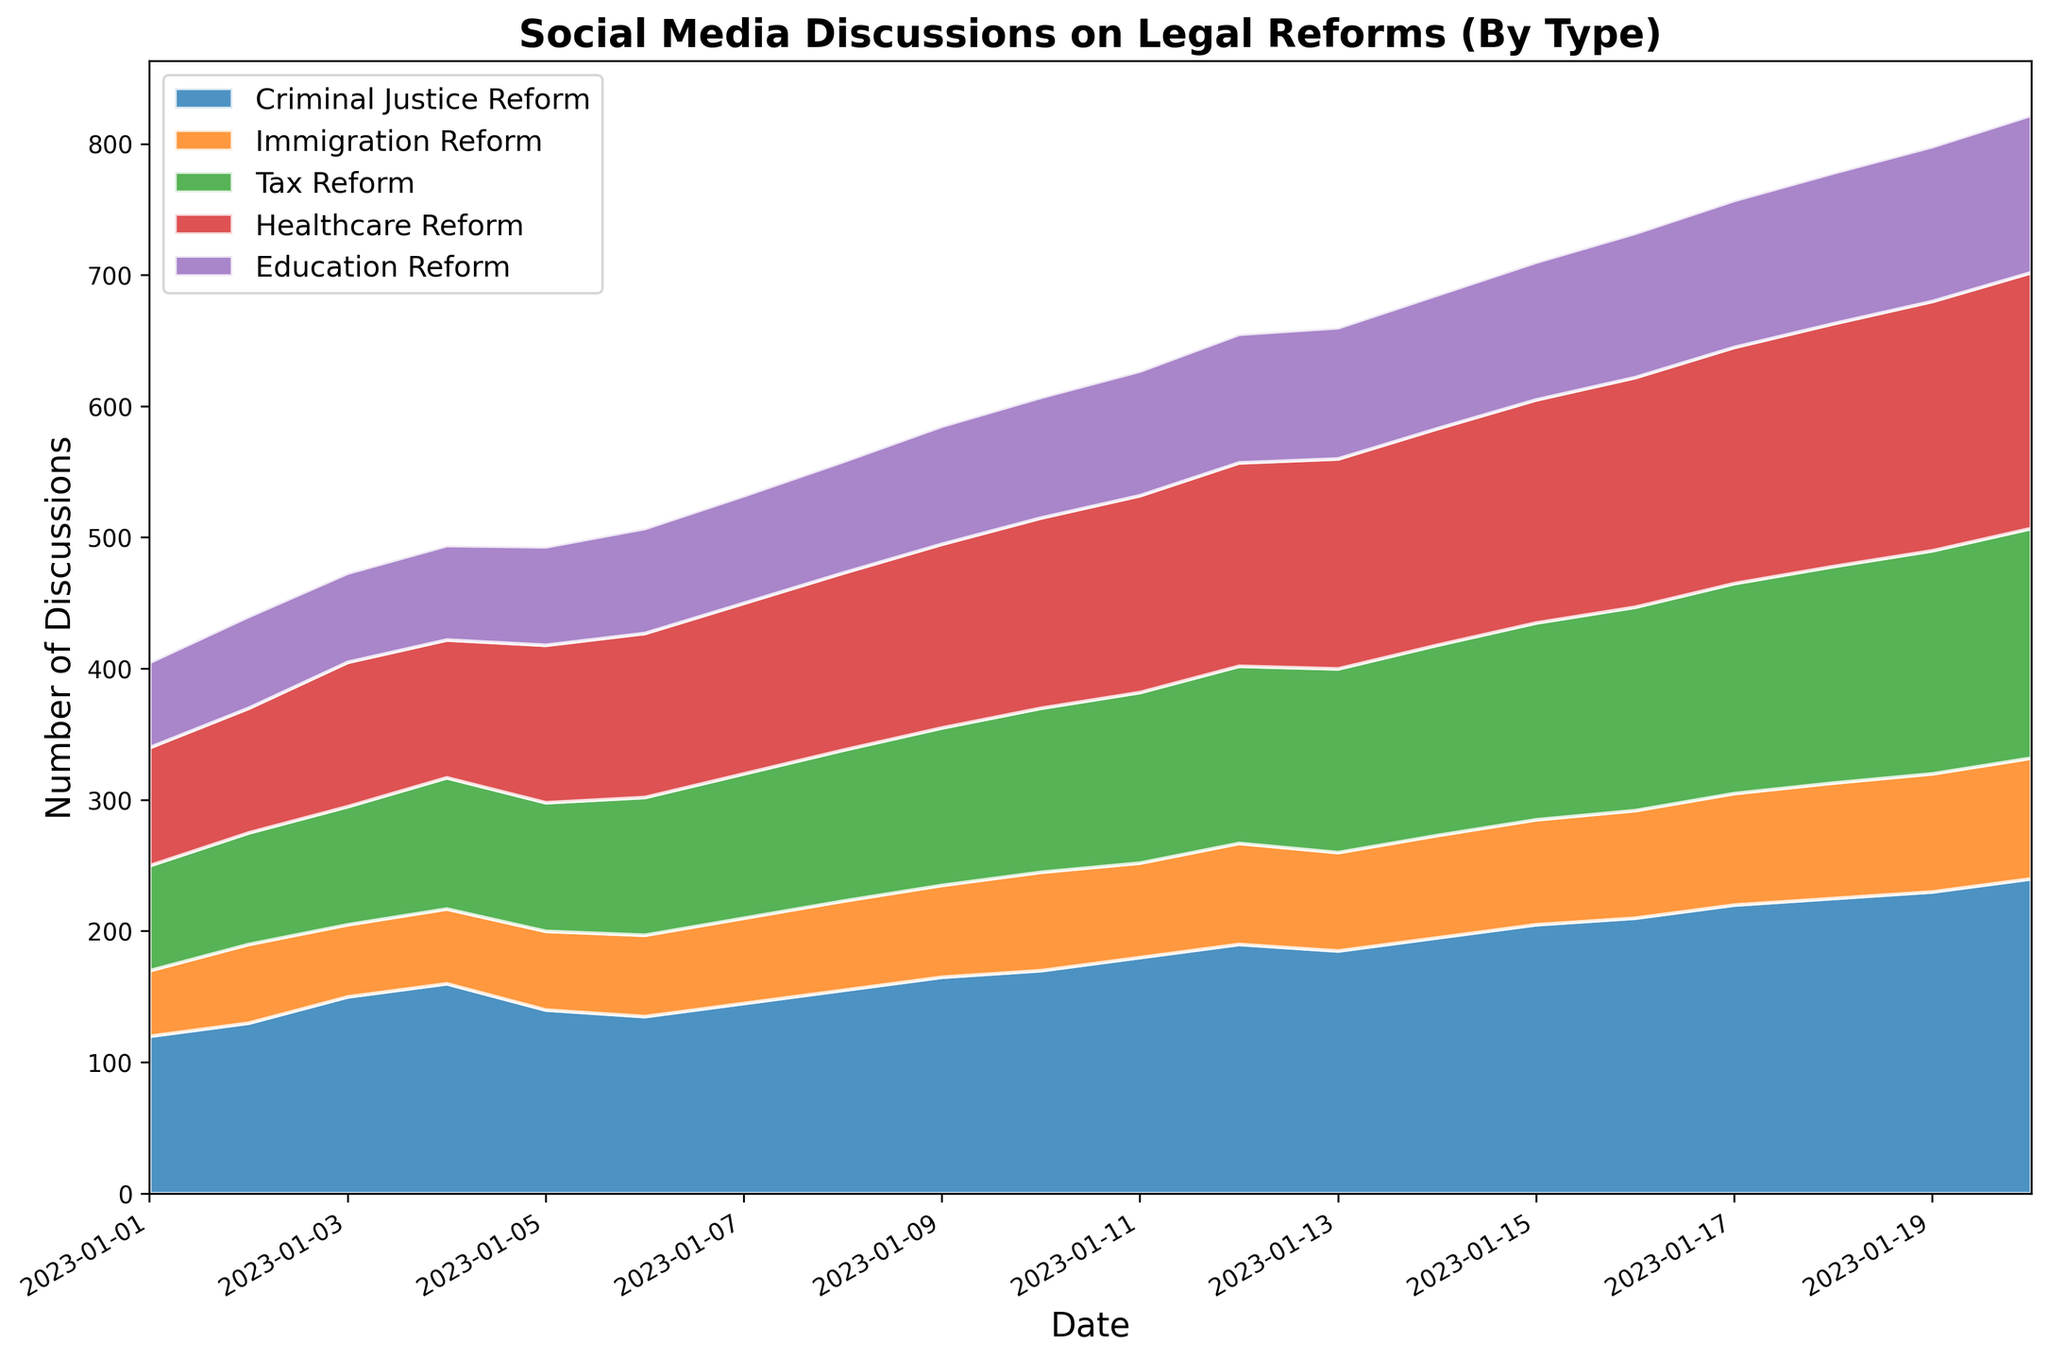Which reform type had the highest peak in discussions? To determine the highest peak in discussions among the reform types, we examine the plot and observe the highest point on the area chart for each category. From the plot, Criminal Justice Reform shows the highest peak.
Answer: Criminal Justice Reform On which date did Immigration Reform first reach 90 discussions? To find the date when Immigration Reform first reached 90 discussions, we look for the point in the figure where the Immigration Reform area first hits the y-axis value of 90. This happens on January 19, 2023.
Answer: 2023-01-19 What is the difference in discussions between Healthcare Reform and Tax Reform on January 10, 2023? To find this difference, we locate January 10, 2023 on the x-axis and look at the heights for both Healthcare Reform and Tax Reform. Healthcare Reform had 145 discussions and Tax Reform had 125 discussions. The difference is 145 - 125.
Answer: 20 Which two reforms had the closest number of discussions on January 15, 2023? We examine the values on January 15, 2023 and compare the discussion numbers of each reform type. Education Reform had 105 discussions and Immigration Reform had 80 discussions, and Healthcare Reform had 170 discussions. The closest numbers are for Education Reform and Tax Reform (105 and 150).
Answer: Education Reform and Tax Reform How did the number of discussions on Education Reform change from January 1 to January 20, 2023? To understand how discussions around Education Reform changed, we track January 1 (65 discussions) and compare it to January 20 (120 discussions). The change is calculated as 120 - 65, which means the discussions increased by 55.
Answer: Increased by 55 What is the combined number of discussions for all reforms on January 4, 2023? To calculate the combined number of discussions on January 4, 2023, we sum the discussions for each reform: Criminal Justice Reform (160), Immigration Reform (57), Tax Reform (100), Healthcare Reform (105), and Education Reform (72). The sum is 160 + 57 + 100 + 105 + 72.
Answer: 494 Which reform shows the most consistent increase without fluctuations over the observed period? To identify the most consistent increase, analyze the trajectories of each reform type. Criminal Justice Reform consistently increases, with a steady rise without any visible drops.
Answer: Criminal Justice Reform How many days did it take for Healthcare Reform discussions to increase from 90 to 150? Locate the first date when Healthcare Reform had 90 discussions (January 1, 2023) and the first date it reached 150 discussions (January 11, 2023). The difference between January 11 and January 1 is 10 days.
Answer: 10 days 